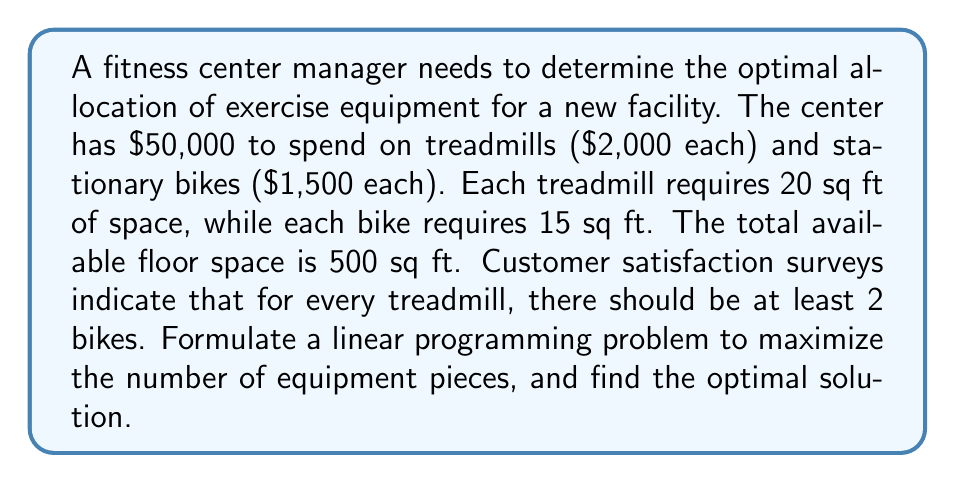What is the answer to this math problem? Let's approach this step-by-step:

1) Define variables:
   Let $x$ = number of treadmills
   Let $y$ = number of stationary bikes

2) Objective function:
   Maximize $z = x + y$ (total number of equipment pieces)

3) Constraints:
   a) Budget constraint: $2000x + 1500y \leq 50000$
   b) Space constraint: $20x + 15y \leq 500$
   c) Customer satisfaction constraint: $y \geq 2x$
   d) Non-negativity: $x \geq 0, y \geq 0$

4) Simplify constraints:
   a) $4x + 3y \leq 100$
   b) $4x + 3y \leq 100$
   c) $-2x + y \geq 0$

5) Graph the feasible region:
   [asy]
   import graph;
   size(200);
   xaxis("x", 0, 25);
   yaxis("y", 0, 35);
   draw((0,0)--(25,16.67), green);
   draw((0,0)--(25,16.67), blue);
   draw((0,0)--(50,100), red);
   label("Budget & Space", (12,8), E);
   label("Customer Satisfaction", (10,20), NW);
   fill((0,0)--(0,33.33)--(16.67,33.33)--(25,16.67)--(0,0), lightgray);
   [/asy]

6) Find corner points:
   (0, 0), (0, 33.33), (16.67, 33.33), (25, 16.67)

7) Evaluate objective function at corner points:
   (0, 0): z = 0
   (0, 33.33): z = 33.33
   (16.67, 33.33): z = 50
   (25, 16.67): z = 41.67

8) The maximum value occurs at (16.67, 33.33)

9) Round down to integer values: 16 treadmills and 33 stationary bikes
Answer: 16 treadmills, 33 stationary bikes 